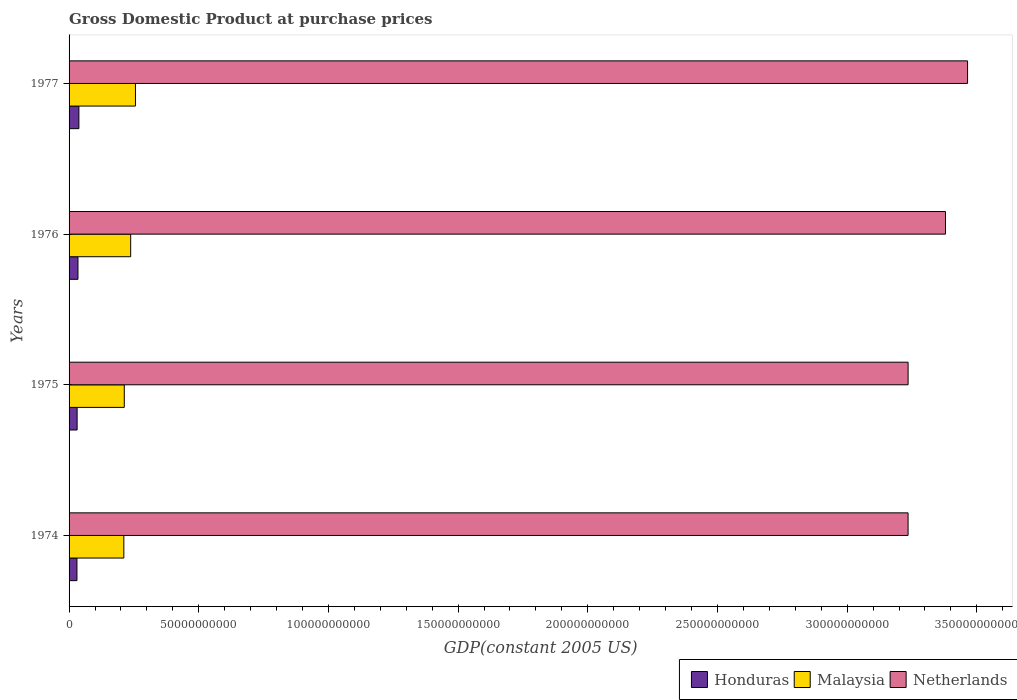How many groups of bars are there?
Your answer should be very brief. 4. Are the number of bars per tick equal to the number of legend labels?
Keep it short and to the point. Yes. How many bars are there on the 4th tick from the bottom?
Give a very brief answer. 3. What is the label of the 1st group of bars from the top?
Keep it short and to the point. 1977. In how many cases, is the number of bars for a given year not equal to the number of legend labels?
Provide a succinct answer. 0. What is the GDP at purchase prices in Honduras in 1975?
Offer a very short reply. 3.10e+09. Across all years, what is the maximum GDP at purchase prices in Honduras?
Your answer should be very brief. 3.79e+09. Across all years, what is the minimum GDP at purchase prices in Malaysia?
Ensure brevity in your answer.  2.11e+1. In which year was the GDP at purchase prices in Honduras minimum?
Keep it short and to the point. 1974. What is the total GDP at purchase prices in Malaysia in the graph?
Offer a very short reply. 9.18e+1. What is the difference between the GDP at purchase prices in Netherlands in 1974 and that in 1976?
Provide a short and direct response. -1.44e+1. What is the difference between the GDP at purchase prices in Netherlands in 1977 and the GDP at purchase prices in Honduras in 1974?
Offer a terse response. 3.43e+11. What is the average GDP at purchase prices in Malaysia per year?
Your answer should be very brief. 2.29e+1. In the year 1974, what is the difference between the GDP at purchase prices in Malaysia and GDP at purchase prices in Honduras?
Keep it short and to the point. 1.81e+1. What is the ratio of the GDP at purchase prices in Malaysia in 1974 to that in 1975?
Offer a terse response. 0.99. Is the difference between the GDP at purchase prices in Malaysia in 1975 and 1976 greater than the difference between the GDP at purchase prices in Honduras in 1975 and 1976?
Provide a succinct answer. No. What is the difference between the highest and the second highest GDP at purchase prices in Netherlands?
Provide a short and direct response. 8.52e+09. What is the difference between the highest and the lowest GDP at purchase prices in Honduras?
Offer a very short reply. 7.47e+08. What does the 3rd bar from the top in 1974 represents?
Provide a short and direct response. Honduras. How many years are there in the graph?
Offer a very short reply. 4. What is the difference between two consecutive major ticks on the X-axis?
Make the answer very short. 5.00e+1. Are the values on the major ticks of X-axis written in scientific E-notation?
Provide a succinct answer. No. Does the graph contain any zero values?
Provide a short and direct response. No. Where does the legend appear in the graph?
Ensure brevity in your answer.  Bottom right. How many legend labels are there?
Offer a very short reply. 3. What is the title of the graph?
Offer a terse response. Gross Domestic Product at purchase prices. Does "Nicaragua" appear as one of the legend labels in the graph?
Your answer should be compact. No. What is the label or title of the X-axis?
Your answer should be compact. GDP(constant 2005 US). What is the GDP(constant 2005 US) in Honduras in 1974?
Offer a terse response. 3.04e+09. What is the GDP(constant 2005 US) in Malaysia in 1974?
Ensure brevity in your answer.  2.11e+1. What is the GDP(constant 2005 US) of Netherlands in 1974?
Ensure brevity in your answer.  3.23e+11. What is the GDP(constant 2005 US) in Honduras in 1975?
Give a very brief answer. 3.10e+09. What is the GDP(constant 2005 US) in Malaysia in 1975?
Give a very brief answer. 2.13e+1. What is the GDP(constant 2005 US) in Netherlands in 1975?
Provide a short and direct response. 3.23e+11. What is the GDP(constant 2005 US) in Honduras in 1976?
Give a very brief answer. 3.43e+09. What is the GDP(constant 2005 US) in Malaysia in 1976?
Offer a very short reply. 2.38e+1. What is the GDP(constant 2005 US) in Netherlands in 1976?
Provide a succinct answer. 3.38e+11. What is the GDP(constant 2005 US) in Honduras in 1977?
Offer a very short reply. 3.79e+09. What is the GDP(constant 2005 US) of Malaysia in 1977?
Offer a very short reply. 2.56e+1. What is the GDP(constant 2005 US) in Netherlands in 1977?
Ensure brevity in your answer.  3.46e+11. Across all years, what is the maximum GDP(constant 2005 US) in Honduras?
Offer a very short reply. 3.79e+09. Across all years, what is the maximum GDP(constant 2005 US) in Malaysia?
Offer a terse response. 2.56e+1. Across all years, what is the maximum GDP(constant 2005 US) in Netherlands?
Ensure brevity in your answer.  3.46e+11. Across all years, what is the minimum GDP(constant 2005 US) in Honduras?
Provide a succinct answer. 3.04e+09. Across all years, what is the minimum GDP(constant 2005 US) in Malaysia?
Offer a terse response. 2.11e+1. Across all years, what is the minimum GDP(constant 2005 US) in Netherlands?
Provide a short and direct response. 3.23e+11. What is the total GDP(constant 2005 US) in Honduras in the graph?
Your answer should be very brief. 1.34e+1. What is the total GDP(constant 2005 US) in Malaysia in the graph?
Keep it short and to the point. 9.18e+1. What is the total GDP(constant 2005 US) of Netherlands in the graph?
Your response must be concise. 1.33e+12. What is the difference between the GDP(constant 2005 US) in Honduras in 1974 and that in 1975?
Your answer should be very brief. -6.48e+07. What is the difference between the GDP(constant 2005 US) in Malaysia in 1974 and that in 1975?
Your answer should be very brief. -1.69e+08. What is the difference between the GDP(constant 2005 US) in Netherlands in 1974 and that in 1975?
Give a very brief answer. -6.56e+06. What is the difference between the GDP(constant 2005 US) in Honduras in 1974 and that in 1976?
Your answer should be very brief. -3.91e+08. What is the difference between the GDP(constant 2005 US) in Malaysia in 1974 and that in 1976?
Give a very brief answer. -2.63e+09. What is the difference between the GDP(constant 2005 US) in Netherlands in 1974 and that in 1976?
Ensure brevity in your answer.  -1.44e+1. What is the difference between the GDP(constant 2005 US) of Honduras in 1974 and that in 1977?
Make the answer very short. -7.47e+08. What is the difference between the GDP(constant 2005 US) in Malaysia in 1974 and that in 1977?
Make the answer very short. -4.47e+09. What is the difference between the GDP(constant 2005 US) in Netherlands in 1974 and that in 1977?
Provide a short and direct response. -2.29e+1. What is the difference between the GDP(constant 2005 US) in Honduras in 1975 and that in 1976?
Keep it short and to the point. -3.26e+08. What is the difference between the GDP(constant 2005 US) of Malaysia in 1975 and that in 1976?
Give a very brief answer. -2.46e+09. What is the difference between the GDP(constant 2005 US) of Netherlands in 1975 and that in 1976?
Your response must be concise. -1.44e+1. What is the difference between the GDP(constant 2005 US) in Honduras in 1975 and that in 1977?
Offer a terse response. -6.82e+08. What is the difference between the GDP(constant 2005 US) in Malaysia in 1975 and that in 1977?
Your answer should be very brief. -4.30e+09. What is the difference between the GDP(constant 2005 US) in Netherlands in 1975 and that in 1977?
Your response must be concise. -2.29e+1. What is the difference between the GDP(constant 2005 US) in Honduras in 1976 and that in 1977?
Provide a succinct answer. -3.56e+08. What is the difference between the GDP(constant 2005 US) of Malaysia in 1976 and that in 1977?
Provide a short and direct response. -1.84e+09. What is the difference between the GDP(constant 2005 US) in Netherlands in 1976 and that in 1977?
Provide a short and direct response. -8.52e+09. What is the difference between the GDP(constant 2005 US) in Honduras in 1974 and the GDP(constant 2005 US) in Malaysia in 1975?
Offer a very short reply. -1.82e+1. What is the difference between the GDP(constant 2005 US) in Honduras in 1974 and the GDP(constant 2005 US) in Netherlands in 1975?
Your answer should be very brief. -3.20e+11. What is the difference between the GDP(constant 2005 US) in Malaysia in 1974 and the GDP(constant 2005 US) in Netherlands in 1975?
Make the answer very short. -3.02e+11. What is the difference between the GDP(constant 2005 US) in Honduras in 1974 and the GDP(constant 2005 US) in Malaysia in 1976?
Keep it short and to the point. -2.07e+1. What is the difference between the GDP(constant 2005 US) of Honduras in 1974 and the GDP(constant 2005 US) of Netherlands in 1976?
Keep it short and to the point. -3.35e+11. What is the difference between the GDP(constant 2005 US) of Malaysia in 1974 and the GDP(constant 2005 US) of Netherlands in 1976?
Give a very brief answer. -3.17e+11. What is the difference between the GDP(constant 2005 US) of Honduras in 1974 and the GDP(constant 2005 US) of Malaysia in 1977?
Provide a succinct answer. -2.26e+1. What is the difference between the GDP(constant 2005 US) of Honduras in 1974 and the GDP(constant 2005 US) of Netherlands in 1977?
Your answer should be very brief. -3.43e+11. What is the difference between the GDP(constant 2005 US) in Malaysia in 1974 and the GDP(constant 2005 US) in Netherlands in 1977?
Offer a terse response. -3.25e+11. What is the difference between the GDP(constant 2005 US) in Honduras in 1975 and the GDP(constant 2005 US) in Malaysia in 1976?
Provide a short and direct response. -2.06e+1. What is the difference between the GDP(constant 2005 US) of Honduras in 1975 and the GDP(constant 2005 US) of Netherlands in 1976?
Provide a succinct answer. -3.35e+11. What is the difference between the GDP(constant 2005 US) in Malaysia in 1975 and the GDP(constant 2005 US) in Netherlands in 1976?
Keep it short and to the point. -3.17e+11. What is the difference between the GDP(constant 2005 US) of Honduras in 1975 and the GDP(constant 2005 US) of Malaysia in 1977?
Provide a short and direct response. -2.25e+1. What is the difference between the GDP(constant 2005 US) of Honduras in 1975 and the GDP(constant 2005 US) of Netherlands in 1977?
Provide a short and direct response. -3.43e+11. What is the difference between the GDP(constant 2005 US) in Malaysia in 1975 and the GDP(constant 2005 US) in Netherlands in 1977?
Provide a succinct answer. -3.25e+11. What is the difference between the GDP(constant 2005 US) of Honduras in 1976 and the GDP(constant 2005 US) of Malaysia in 1977?
Your answer should be very brief. -2.22e+1. What is the difference between the GDP(constant 2005 US) of Honduras in 1976 and the GDP(constant 2005 US) of Netherlands in 1977?
Your answer should be compact. -3.43e+11. What is the difference between the GDP(constant 2005 US) of Malaysia in 1976 and the GDP(constant 2005 US) of Netherlands in 1977?
Offer a very short reply. -3.23e+11. What is the average GDP(constant 2005 US) of Honduras per year?
Give a very brief answer. 3.34e+09. What is the average GDP(constant 2005 US) in Malaysia per year?
Provide a short and direct response. 2.29e+1. What is the average GDP(constant 2005 US) of Netherlands per year?
Give a very brief answer. 3.33e+11. In the year 1974, what is the difference between the GDP(constant 2005 US) in Honduras and GDP(constant 2005 US) in Malaysia?
Your response must be concise. -1.81e+1. In the year 1974, what is the difference between the GDP(constant 2005 US) of Honduras and GDP(constant 2005 US) of Netherlands?
Make the answer very short. -3.20e+11. In the year 1974, what is the difference between the GDP(constant 2005 US) in Malaysia and GDP(constant 2005 US) in Netherlands?
Give a very brief answer. -3.02e+11. In the year 1975, what is the difference between the GDP(constant 2005 US) in Honduras and GDP(constant 2005 US) in Malaysia?
Give a very brief answer. -1.82e+1. In the year 1975, what is the difference between the GDP(constant 2005 US) in Honduras and GDP(constant 2005 US) in Netherlands?
Make the answer very short. -3.20e+11. In the year 1975, what is the difference between the GDP(constant 2005 US) of Malaysia and GDP(constant 2005 US) of Netherlands?
Give a very brief answer. -3.02e+11. In the year 1976, what is the difference between the GDP(constant 2005 US) in Honduras and GDP(constant 2005 US) in Malaysia?
Your answer should be compact. -2.03e+1. In the year 1976, what is the difference between the GDP(constant 2005 US) of Honduras and GDP(constant 2005 US) of Netherlands?
Keep it short and to the point. -3.34e+11. In the year 1976, what is the difference between the GDP(constant 2005 US) of Malaysia and GDP(constant 2005 US) of Netherlands?
Ensure brevity in your answer.  -3.14e+11. In the year 1977, what is the difference between the GDP(constant 2005 US) in Honduras and GDP(constant 2005 US) in Malaysia?
Your response must be concise. -2.18e+1. In the year 1977, what is the difference between the GDP(constant 2005 US) in Honduras and GDP(constant 2005 US) in Netherlands?
Your answer should be compact. -3.43e+11. In the year 1977, what is the difference between the GDP(constant 2005 US) of Malaysia and GDP(constant 2005 US) of Netherlands?
Provide a succinct answer. -3.21e+11. What is the ratio of the GDP(constant 2005 US) in Honduras in 1974 to that in 1975?
Ensure brevity in your answer.  0.98. What is the ratio of the GDP(constant 2005 US) in Malaysia in 1974 to that in 1975?
Ensure brevity in your answer.  0.99. What is the ratio of the GDP(constant 2005 US) of Honduras in 1974 to that in 1976?
Ensure brevity in your answer.  0.89. What is the ratio of the GDP(constant 2005 US) of Malaysia in 1974 to that in 1976?
Ensure brevity in your answer.  0.89. What is the ratio of the GDP(constant 2005 US) of Netherlands in 1974 to that in 1976?
Provide a short and direct response. 0.96. What is the ratio of the GDP(constant 2005 US) of Honduras in 1974 to that in 1977?
Your response must be concise. 0.8. What is the ratio of the GDP(constant 2005 US) in Malaysia in 1974 to that in 1977?
Give a very brief answer. 0.83. What is the ratio of the GDP(constant 2005 US) of Netherlands in 1974 to that in 1977?
Your response must be concise. 0.93. What is the ratio of the GDP(constant 2005 US) of Honduras in 1975 to that in 1976?
Keep it short and to the point. 0.91. What is the ratio of the GDP(constant 2005 US) of Malaysia in 1975 to that in 1976?
Provide a succinct answer. 0.9. What is the ratio of the GDP(constant 2005 US) in Netherlands in 1975 to that in 1976?
Make the answer very short. 0.96. What is the ratio of the GDP(constant 2005 US) of Honduras in 1975 to that in 1977?
Your answer should be very brief. 0.82. What is the ratio of the GDP(constant 2005 US) in Malaysia in 1975 to that in 1977?
Offer a very short reply. 0.83. What is the ratio of the GDP(constant 2005 US) of Netherlands in 1975 to that in 1977?
Your response must be concise. 0.93. What is the ratio of the GDP(constant 2005 US) of Honduras in 1976 to that in 1977?
Ensure brevity in your answer.  0.91. What is the ratio of the GDP(constant 2005 US) in Malaysia in 1976 to that in 1977?
Offer a very short reply. 0.93. What is the ratio of the GDP(constant 2005 US) in Netherlands in 1976 to that in 1977?
Keep it short and to the point. 0.98. What is the difference between the highest and the second highest GDP(constant 2005 US) of Honduras?
Your answer should be very brief. 3.56e+08. What is the difference between the highest and the second highest GDP(constant 2005 US) in Malaysia?
Offer a very short reply. 1.84e+09. What is the difference between the highest and the second highest GDP(constant 2005 US) in Netherlands?
Your answer should be compact. 8.52e+09. What is the difference between the highest and the lowest GDP(constant 2005 US) of Honduras?
Keep it short and to the point. 7.47e+08. What is the difference between the highest and the lowest GDP(constant 2005 US) of Malaysia?
Offer a very short reply. 4.47e+09. What is the difference between the highest and the lowest GDP(constant 2005 US) of Netherlands?
Offer a terse response. 2.29e+1. 